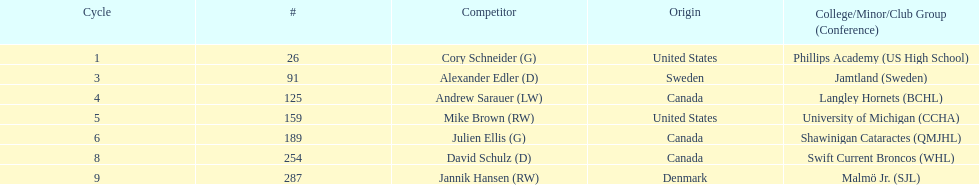Who is the only player to have denmark listed as their nationality? Jannik Hansen (RW). 